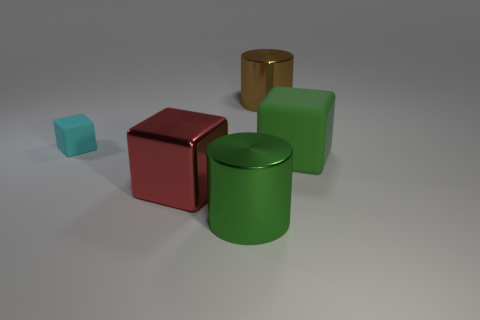Subtract all matte cubes. How many cubes are left? 1 Add 1 small cyan things. How many objects exist? 6 Subtract all blocks. How many objects are left? 2 Subtract 0 brown spheres. How many objects are left? 5 Subtract all brown objects. Subtract all green shiny cylinders. How many objects are left? 3 Add 2 large metallic objects. How many large metallic objects are left? 5 Add 4 big metal cylinders. How many big metal cylinders exist? 6 